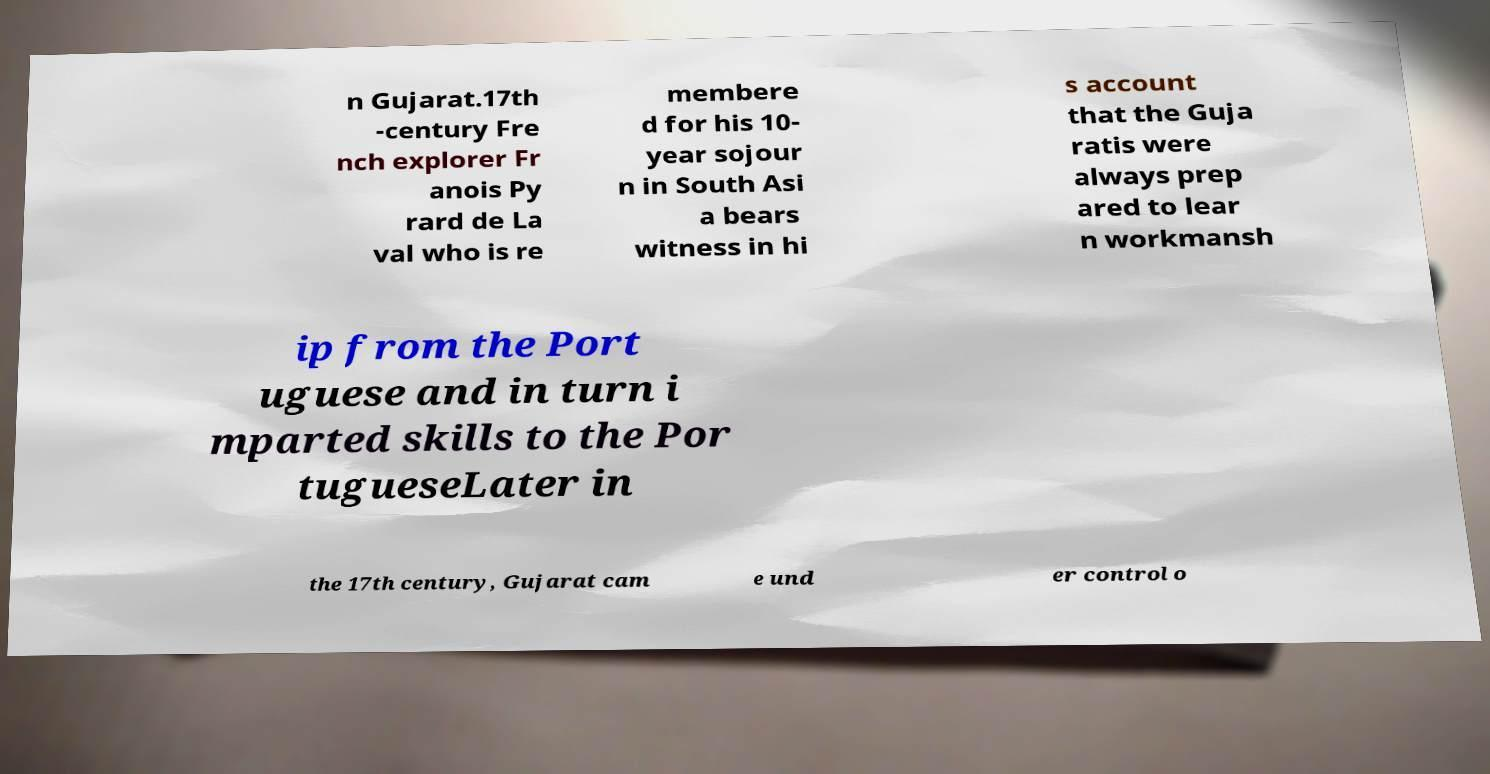Please read and relay the text visible in this image. What does it say? n Gujarat.17th -century Fre nch explorer Fr anois Py rard de La val who is re membere d for his 10- year sojour n in South Asi a bears witness in hi s account that the Guja ratis were always prep ared to lear n workmansh ip from the Port uguese and in turn i mparted skills to the Por tugueseLater in the 17th century, Gujarat cam e und er control o 